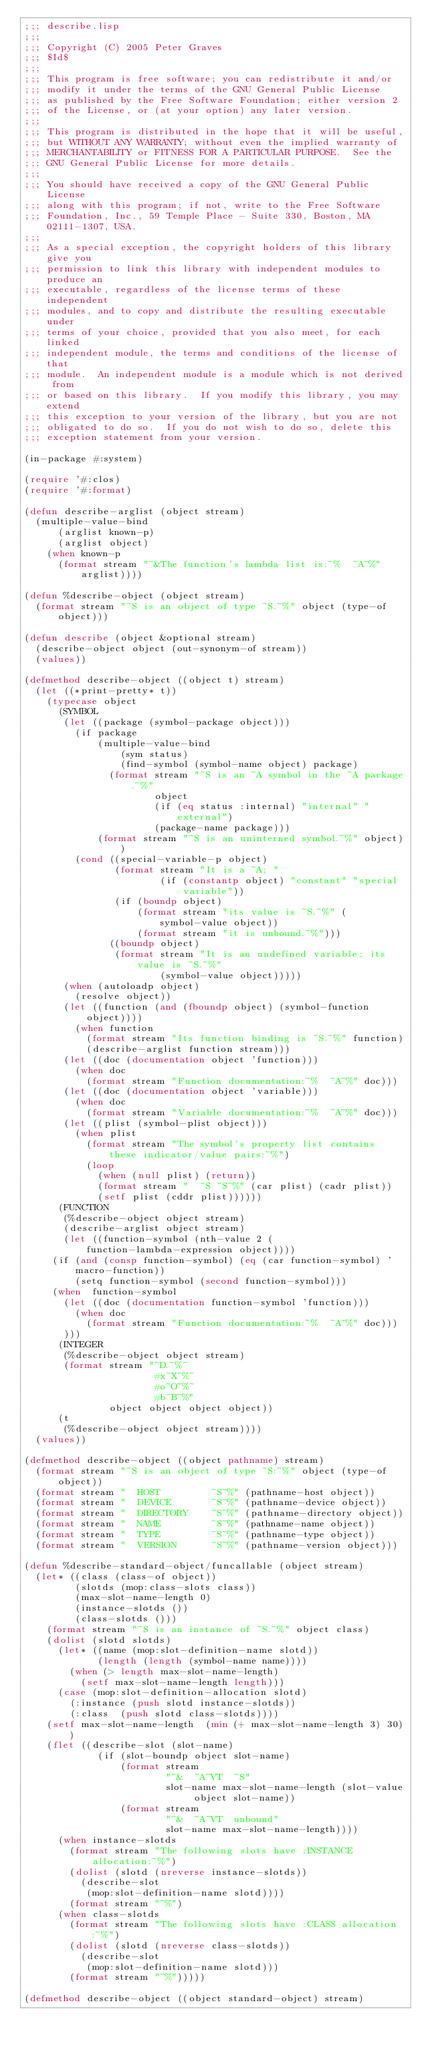Convert code to text. <code><loc_0><loc_0><loc_500><loc_500><_Lisp_>;;; describe.lisp
;;;
;;; Copyright (C) 2005 Peter Graves
;;; $Id$
;;;
;;; This program is free software; you can redistribute it and/or
;;; modify it under the terms of the GNU General Public License
;;; as published by the Free Software Foundation; either version 2
;;; of the License, or (at your option) any later version.
;;;
;;; This program is distributed in the hope that it will be useful,
;;; but WITHOUT ANY WARRANTY; without even the implied warranty of
;;; MERCHANTABILITY or FITNESS FOR A PARTICULAR PURPOSE.  See the
;;; GNU General Public License for more details.
;;;
;;; You should have received a copy of the GNU General Public License
;;; along with this program; if not, write to the Free Software
;;; Foundation, Inc., 59 Temple Place - Suite 330, Boston, MA  02111-1307, USA.
;;;
;;; As a special exception, the copyright holders of this library give you
;;; permission to link this library with independent modules to produce an
;;; executable, regardless of the license terms of these independent
;;; modules, and to copy and distribute the resulting executable under
;;; terms of your choice, provided that you also meet, for each linked
;;; independent module, the terms and conditions of the license of that
;;; module.  An independent module is a module which is not derived from
;;; or based on this library.  If you modify this library, you may extend
;;; this exception to your version of the library, but you are not
;;; obligated to do so.  If you do not wish to do so, delete this
;;; exception statement from your version.

(in-package #:system)

(require '#:clos)
(require '#:format)

(defun describe-arglist (object stream)
  (multiple-value-bind
      (arglist known-p)
      (arglist object)
    (when known-p
      (format stream "~&The function's lambda list is:~%  ~A~%" arglist))))

(defun %describe-object (object stream)
  (format stream "~S is an object of type ~S.~%" object (type-of object)))

(defun describe (object &optional stream)
  (describe-object object (out-synonym-of stream))
  (values))

(defmethod describe-object ((object t) stream)
  (let ((*print-pretty* t))
    (typecase object
      (SYMBOL
       (let ((package (symbol-package object)))
         (if package
             (multiple-value-bind
                 (sym status)
                 (find-symbol (symbol-name object) package)
               (format stream "~S is an ~A symbol in the ~A package.~%"
                       object
                       (if (eq status :internal) "internal" "external")
                       (package-name package)))
             (format stream "~S is an uninterned symbol.~%" object))
         (cond ((special-variable-p object)
                (format stream "It is a ~A; "
                        (if (constantp object) "constant" "special variable"))
                (if (boundp object)
                    (format stream "its value is ~S.~%" (symbol-value object))
                    (format stream "it is unbound.~%")))
               ((boundp object)
                (format stream "It is an undefined variable; its value is ~S.~%"
                        (symbol-value object)))))
       (when (autoloadp object)
         (resolve object))
       (let ((function (and (fboundp object) (symbol-function object))))
         (when function
           (format stream "Its function binding is ~S.~%" function)
           (describe-arglist function stream)))
       (let ((doc (documentation object 'function)))
         (when doc
           (format stream "Function documentation:~%  ~A~%" doc)))
       (let ((doc (documentation object 'variable)))
         (when doc
           (format stream "Variable documentation:~%  ~A~%" doc)))
       (let ((plist (symbol-plist object)))
         (when plist
           (format stream "The symbol's property list contains these indicator/value pairs:~%")
           (loop
             (when (null plist) (return))
             (format stream "  ~S ~S~%" (car plist) (cadr plist))
             (setf plist (cddr plist))))))
      (FUNCTION
       (%describe-object object stream)
       (describe-arglist object stream)
       (let ((function-symbol (nth-value 2 (function-lambda-expression object))))
	 (if (and (consp function-symbol) (eq (car function-symbol) 'macro-function))
	     (setq function-symbol (second function-symbol)))
	 (when  function-symbol
	   (let ((doc (documentation function-symbol 'function)))
	     (when doc
	       (format stream "Function documentation:~%  ~A~%" doc)))
	   )))
      (INTEGER
       (%describe-object object stream)
       (format stream "~D.~%~
                       #x~X~%~
                       #o~O~%~
                       #b~B~%"
               object object object object))
      (t
       (%describe-object object stream))))
  (values))

(defmethod describe-object ((object pathname) stream)
  (format stream "~S is an object of type ~S:~%" object (type-of object))
  (format stream "  HOST         ~S~%" (pathname-host object))
  (format stream "  DEVICE       ~S~%" (pathname-device object))
  (format stream "  DIRECTORY    ~S~%" (pathname-directory object))
  (format stream "  NAME         ~S~%" (pathname-name object))
  (format stream "  TYPE         ~S~%" (pathname-type object))
  (format stream "  VERSION      ~S~%" (pathname-version object)))

(defun %describe-standard-object/funcallable (object stream)
  (let* ((class (class-of object))
         (slotds (mop:class-slots class))
         (max-slot-name-length 0)
         (instance-slotds ())
         (class-slotds ()))
    (format stream "~S is an instance of ~S.~%" object class)
    (dolist (slotd slotds)
      (let* ((name (mop:slot-definition-name slotd))
             (length (length (symbol-name name))))
        (when (> length max-slot-name-length)
          (setf max-slot-name-length length)))
      (case (mop:slot-definition-allocation slotd)
        (:instance (push slotd instance-slotds))
        (:class  (push slotd class-slotds))))
    (setf max-slot-name-length  (min (+ max-slot-name-length 3) 30))
    (flet ((describe-slot (slot-name)
             (if (slot-boundp object slot-name)
                 (format stream
                         "~&  ~A~VT  ~S"
                         slot-name max-slot-name-length (slot-value object slot-name))
                 (format stream
                         "~&  ~A~VT  unbound"
                         slot-name max-slot-name-length))))
      (when instance-slotds
        (format stream "The following slots have :INSTANCE allocation:~%")
        (dolist (slotd (nreverse instance-slotds))
          (describe-slot
           (mop:slot-definition-name slotd))))
        (format stream "~%")
      (when class-slotds
        (format stream "The following slots have :CLASS allocation:~%")
        (dolist (slotd (nreverse class-slotds))
          (describe-slot
           (mop:slot-definition-name slotd)))
        (format stream "~%")))))

(defmethod describe-object ((object standard-object) stream)</code> 